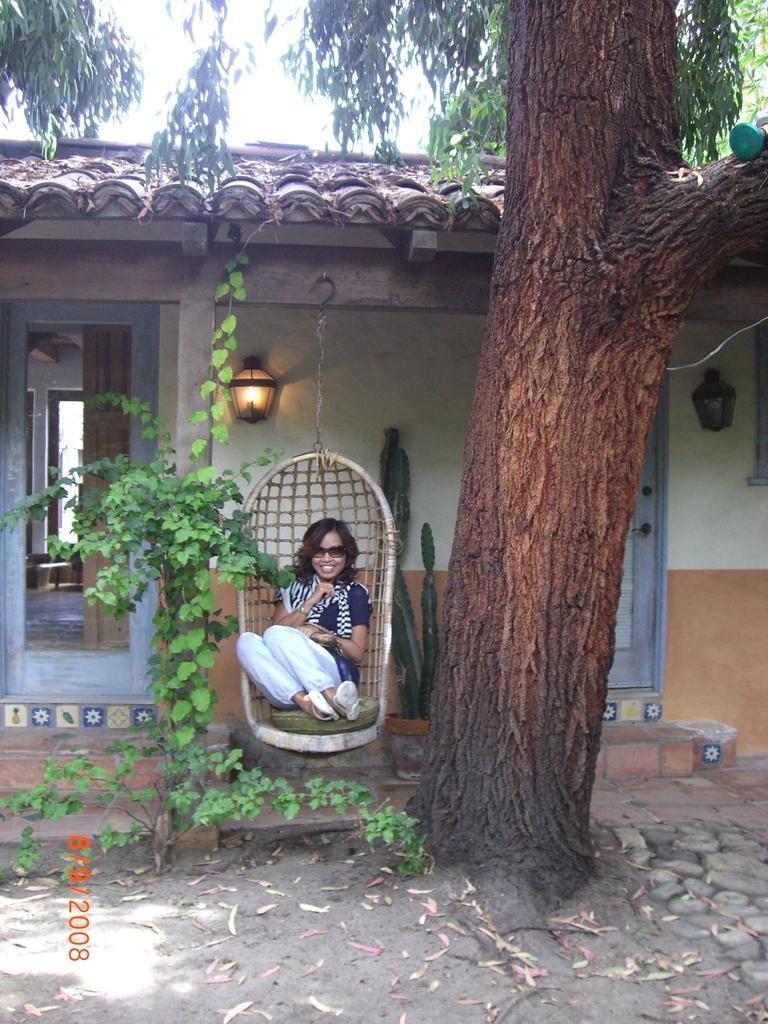Could you give a brief overview of what you see in this image? In this image we can see there is a house with doors and lights. In front of the house there is a person sitting on the swing chair. And there is a potted plant, tree, leaves and the sky. 